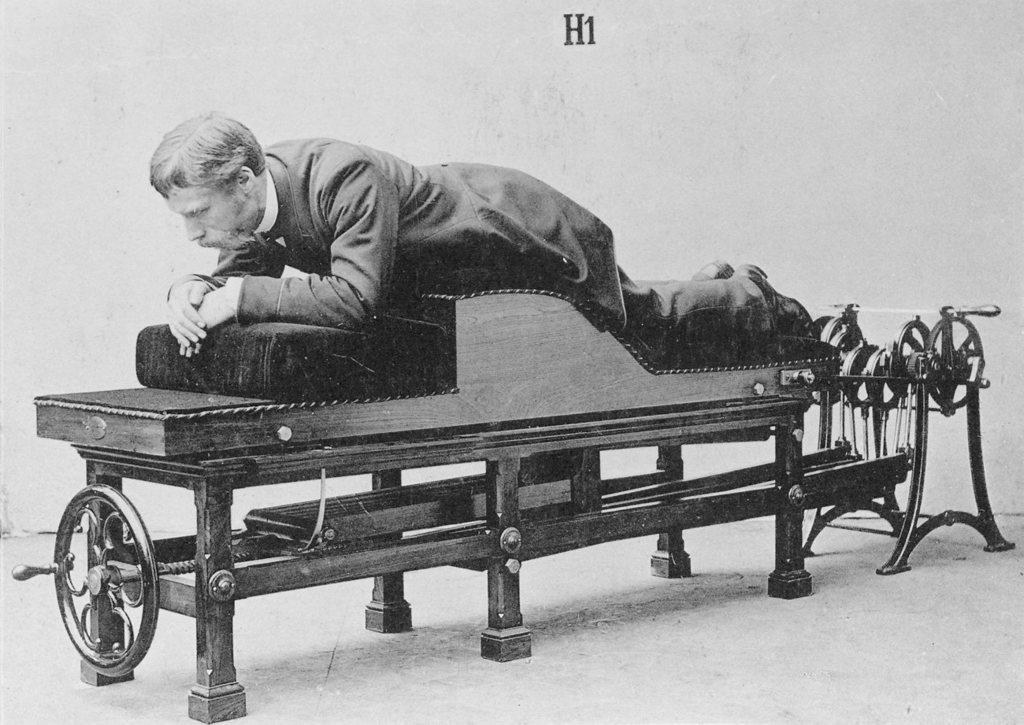What is the color scheme of the image? The image is in black and white. Who is present in the image? There is a man in the image. What is the man doing in the image? The man is sleeping. What is the man lying on in the image? The man is on an equipment. What type of cord is being used by the man in the image? There is no cord present in the image; the man is simply sleeping on an equipment. 